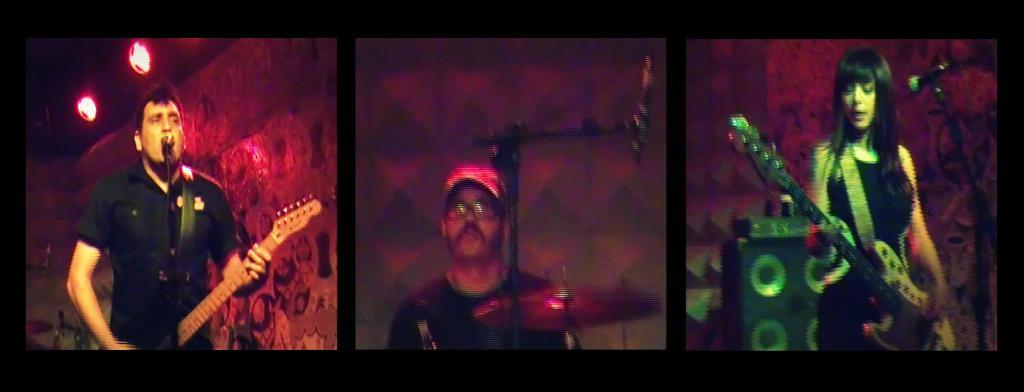What is the main subject of the image? The main subject of the image is a collage of pictures. How many people are featured in the collage? There are two men and a woman in the collage. What are the men holding in the collage? Both men are holding guitars. Can you describe the location of one of the men in relation to a musical instrument? One man is near a musical instrument. What type of growth can be seen in the garden featured in the image? There is no garden present in the image; it is a collage of pictures featuring two men and a woman. How many teeth can be seen in the image? There are no teeth visible in the image, as it is a collage of pictures featuring people and musical instruments. 